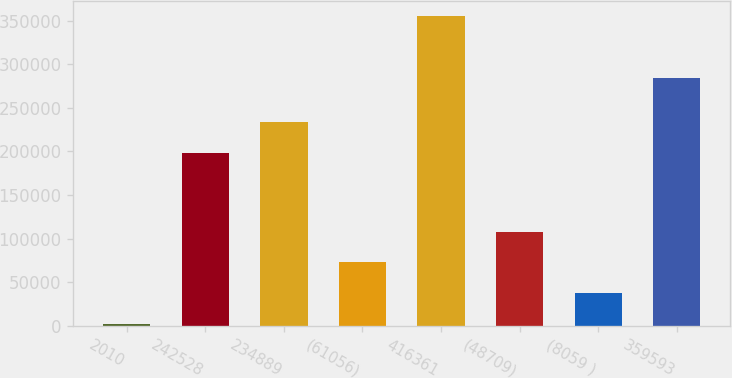<chart> <loc_0><loc_0><loc_500><loc_500><bar_chart><fcel>2010<fcel>242528<fcel>234889<fcel>(61056)<fcel>416361<fcel>(48709)<fcel>(8059 )<fcel>359593<nl><fcel>2008<fcel>197838<fcel>233150<fcel>72633<fcel>355133<fcel>107946<fcel>37320.5<fcel>283922<nl></chart> 